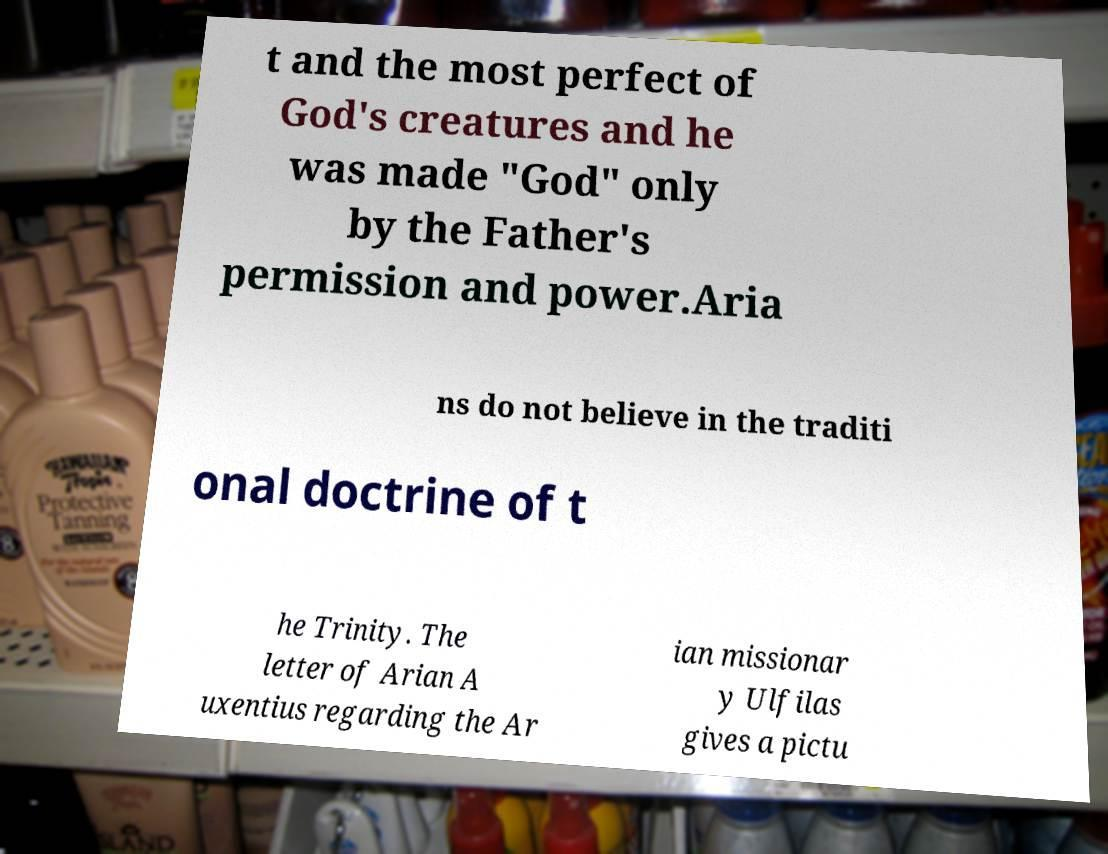For documentation purposes, I need the text within this image transcribed. Could you provide that? t and the most perfect of God's creatures and he was made "God" only by the Father's permission and power.Aria ns do not believe in the traditi onal doctrine of t he Trinity. The letter of Arian A uxentius regarding the Ar ian missionar y Ulfilas gives a pictu 